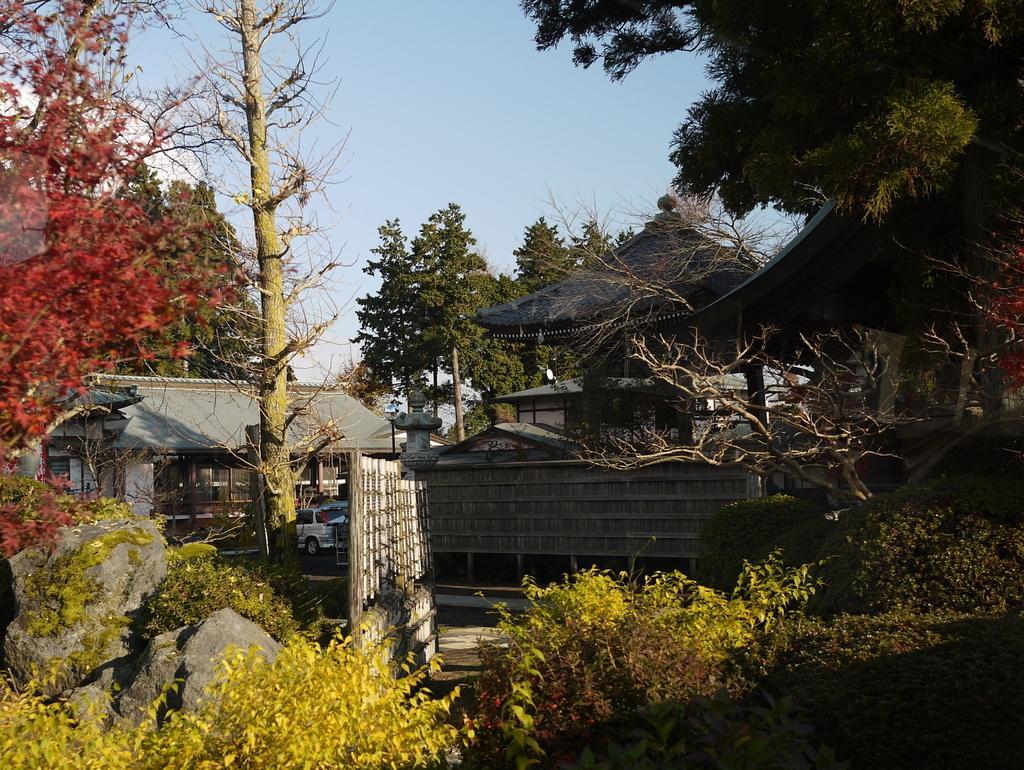How would you summarize this image in a sentence or two? In this picture there are houses and cars in the center of the image and there is greenery around the area of the image. 